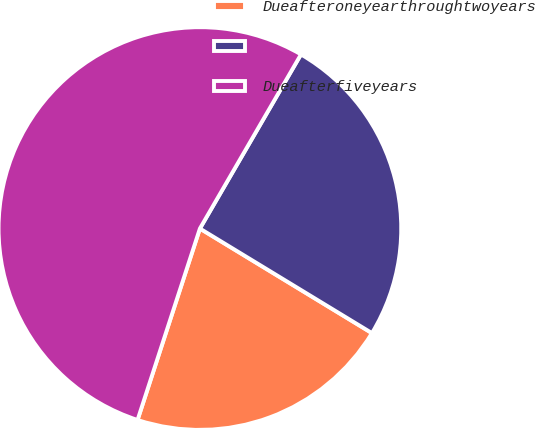Convert chart to OTSL. <chart><loc_0><loc_0><loc_500><loc_500><pie_chart><fcel>Dueafteroneyearthroughtwoyears<fcel>Unnamed: 1<fcel>Dueafterfiveyears<nl><fcel>21.32%<fcel>25.32%<fcel>53.36%<nl></chart> 